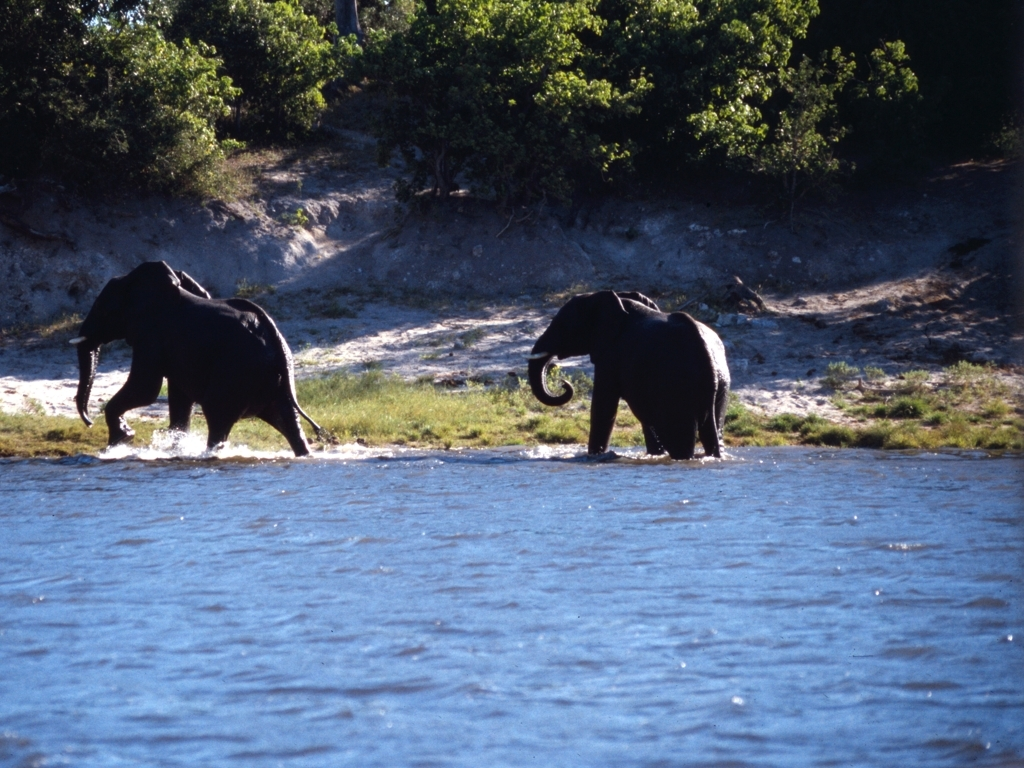Are the two ends of the subject backlit?
A. No
B. Yes
Answer with the option's letter from the given choices directly.
 B. 